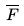<formula> <loc_0><loc_0><loc_500><loc_500>\overline { F }</formula> 